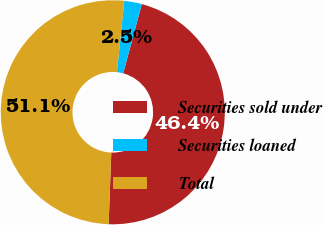Convert chart. <chart><loc_0><loc_0><loc_500><loc_500><pie_chart><fcel>Securities sold under<fcel>Securities loaned<fcel>Total<nl><fcel>46.42%<fcel>2.53%<fcel>51.06%<nl></chart> 